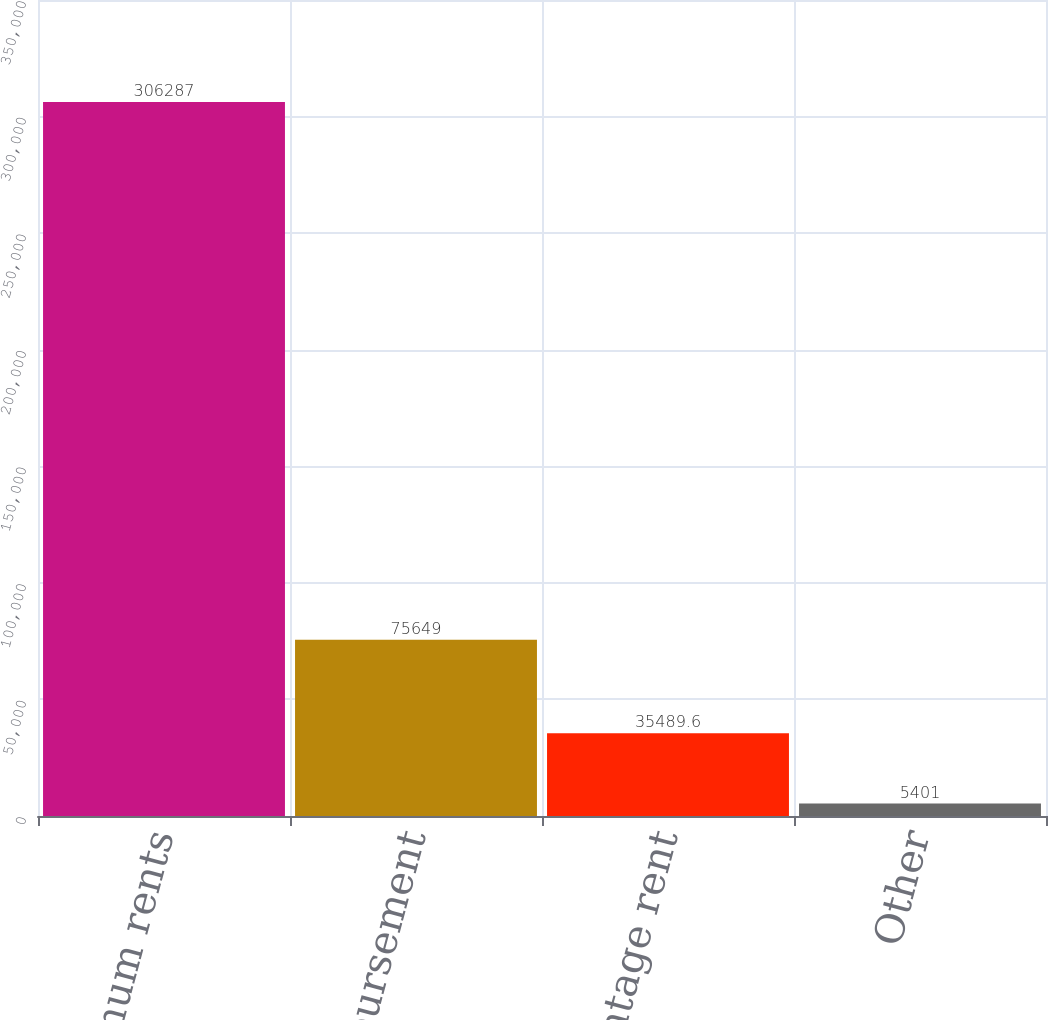Convert chart. <chart><loc_0><loc_0><loc_500><loc_500><bar_chart><fcel>Minimum rents<fcel>Cost reimbursement<fcel>Percentage rent<fcel>Other<nl><fcel>306287<fcel>75649<fcel>35489.6<fcel>5401<nl></chart> 